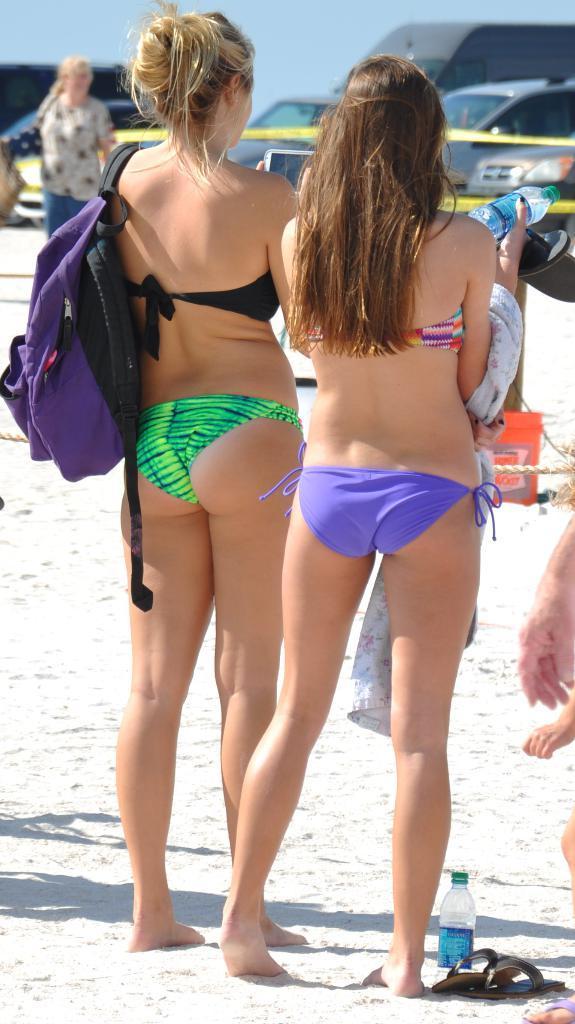Describe this image in one or two sentences. In this image, we can see two women standing, in the background there are some cars and at the top there is a sky. 